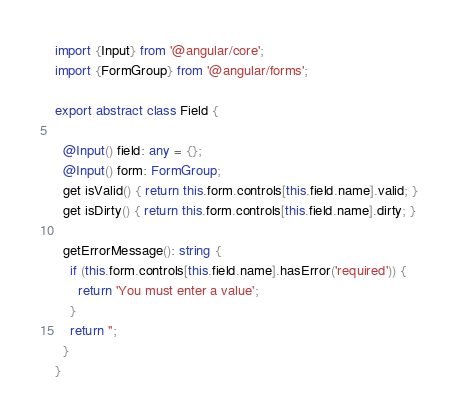<code> <loc_0><loc_0><loc_500><loc_500><_TypeScript_>import {Input} from '@angular/core';
import {FormGroup} from '@angular/forms';

export abstract class Field {

  @Input() field: any = {};
  @Input() form: FormGroup;
  get isValid() { return this.form.controls[this.field.name].valid; }
  get isDirty() { return this.form.controls[this.field.name].dirty; }

  getErrorMessage(): string {
    if (this.form.controls[this.field.name].hasError('required')) {
      return 'You must enter a value';
    }
    return '';
  }
}
</code> 